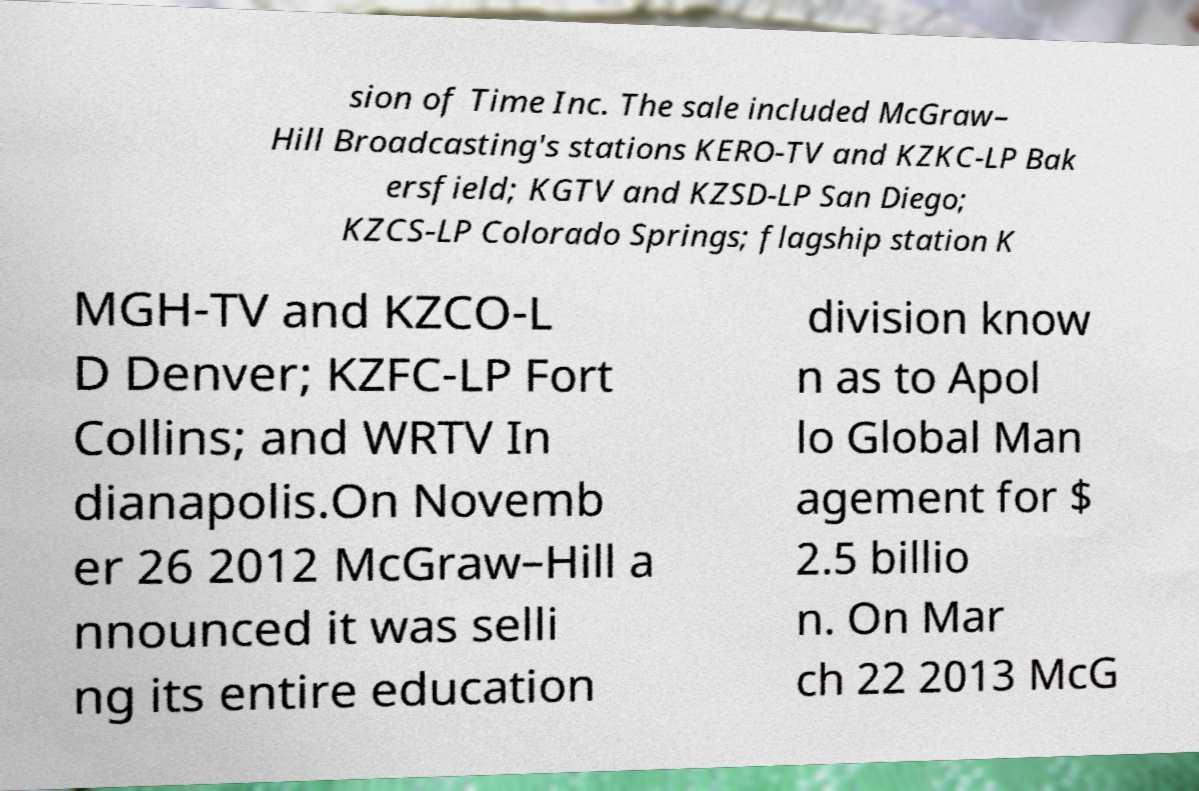For documentation purposes, I need the text within this image transcribed. Could you provide that? sion of Time Inc. The sale included McGraw– Hill Broadcasting's stations KERO-TV and KZKC-LP Bak ersfield; KGTV and KZSD-LP San Diego; KZCS-LP Colorado Springs; flagship station K MGH-TV and KZCO-L D Denver; KZFC-LP Fort Collins; and WRTV In dianapolis.On Novemb er 26 2012 McGraw–Hill a nnounced it was selli ng its entire education division know n as to Apol lo Global Man agement for $ 2.5 billio n. On Mar ch 22 2013 McG 